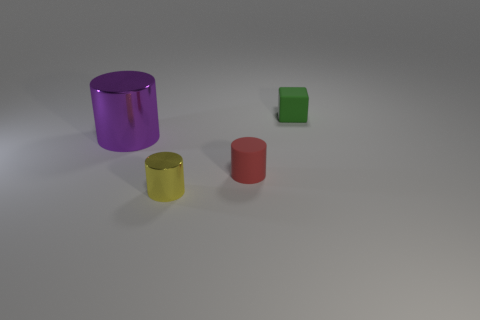How many green objects are the same material as the small red object?
Make the answer very short. 1. How many things are either metal cylinders that are left of the yellow shiny object or metal cubes?
Give a very brief answer. 1. What is the size of the green rubber cube?
Provide a succinct answer. Small. The object that is behind the metallic cylinder that is left of the small metal thing is made of what material?
Provide a short and direct response. Rubber. Do the cylinder to the left of the yellow shiny cylinder and the red matte thing have the same size?
Offer a terse response. No. Is there another tiny rubber cube that has the same color as the cube?
Your answer should be very brief. No. How many objects are shiny objects that are behind the yellow shiny cylinder or cylinders that are on the right side of the purple shiny cylinder?
Provide a succinct answer. 3. Are there fewer purple metal things in front of the yellow object than metal objects in front of the large purple metallic thing?
Give a very brief answer. Yes. Is the material of the tiny red cylinder the same as the green thing?
Give a very brief answer. Yes. There is a cylinder that is both to the right of the big purple metal cylinder and on the left side of the small red thing; what size is it?
Offer a terse response. Small. 